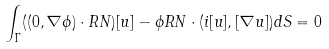Convert formula to latex. <formula><loc_0><loc_0><loc_500><loc_500>\int _ { \Gamma } ( ( 0 , \nabla \phi ) \cdot R N ) [ u ] - \phi R N \cdot ( i [ u ] , [ \nabla u ] ) d S = 0</formula> 